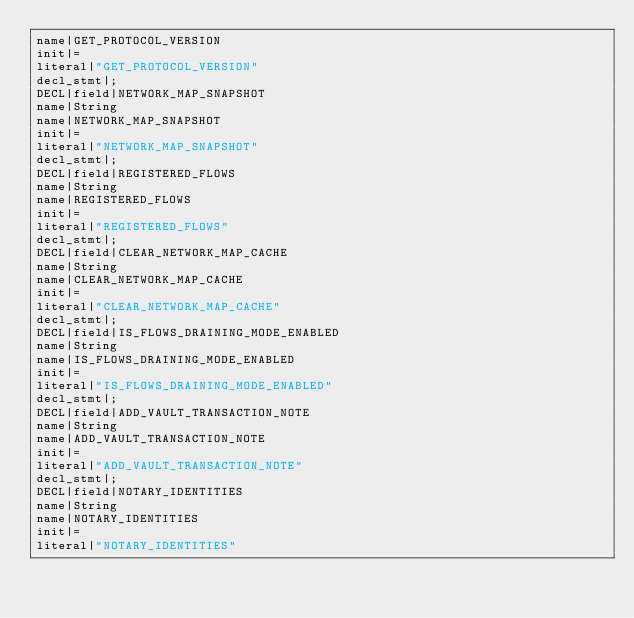<code> <loc_0><loc_0><loc_500><loc_500><_Java_>name|GET_PROTOCOL_VERSION
init|=
literal|"GET_PROTOCOL_VERSION"
decl_stmt|;
DECL|field|NETWORK_MAP_SNAPSHOT
name|String
name|NETWORK_MAP_SNAPSHOT
init|=
literal|"NETWORK_MAP_SNAPSHOT"
decl_stmt|;
DECL|field|REGISTERED_FLOWS
name|String
name|REGISTERED_FLOWS
init|=
literal|"REGISTERED_FLOWS"
decl_stmt|;
DECL|field|CLEAR_NETWORK_MAP_CACHE
name|String
name|CLEAR_NETWORK_MAP_CACHE
init|=
literal|"CLEAR_NETWORK_MAP_CACHE"
decl_stmt|;
DECL|field|IS_FLOWS_DRAINING_MODE_ENABLED
name|String
name|IS_FLOWS_DRAINING_MODE_ENABLED
init|=
literal|"IS_FLOWS_DRAINING_MODE_ENABLED"
decl_stmt|;
DECL|field|ADD_VAULT_TRANSACTION_NOTE
name|String
name|ADD_VAULT_TRANSACTION_NOTE
init|=
literal|"ADD_VAULT_TRANSACTION_NOTE"
decl_stmt|;
DECL|field|NOTARY_IDENTITIES
name|String
name|NOTARY_IDENTITIES
init|=
literal|"NOTARY_IDENTITIES"</code> 